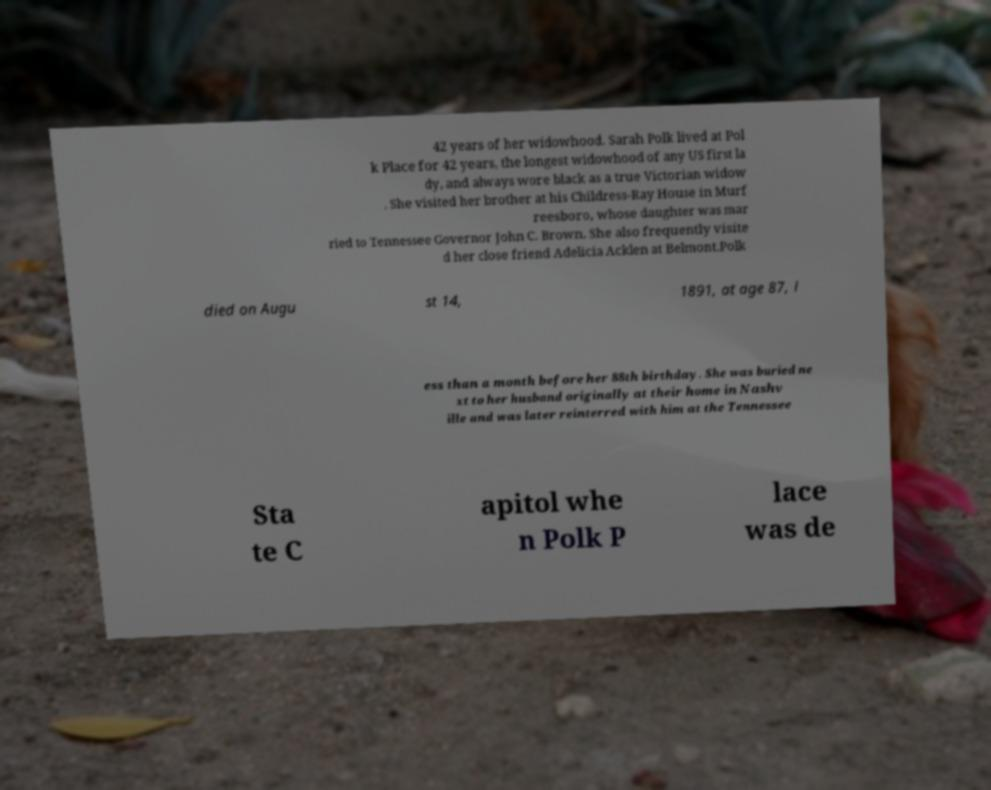Please identify and transcribe the text found in this image. 42 years of her widowhood. Sarah Polk lived at Pol k Place for 42 years, the longest widowhood of any US first la dy, and always wore black as a true Victorian widow . She visited her brother at his Childress-Ray House in Murf reesboro, whose daughter was mar ried to Tennessee Governor John C. Brown. She also frequently visite d her close friend Adelicia Acklen at Belmont.Polk died on Augu st 14, 1891, at age 87, l ess than a month before her 88th birthday. She was buried ne xt to her husband originally at their home in Nashv ille and was later reinterred with him at the Tennessee Sta te C apitol whe n Polk P lace was de 